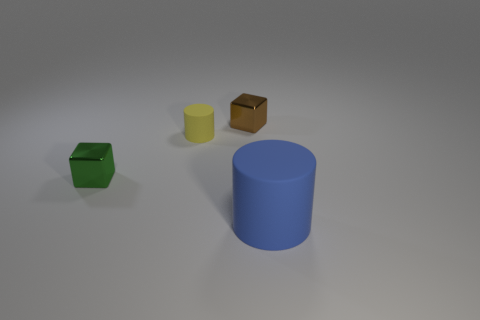Add 1 red shiny objects. How many objects exist? 5 Subtract all small brown metal blocks. Subtract all small matte things. How many objects are left? 2 Add 2 green metallic things. How many green metallic things are left? 3 Add 2 tiny matte things. How many tiny matte things exist? 3 Subtract 0 gray balls. How many objects are left? 4 